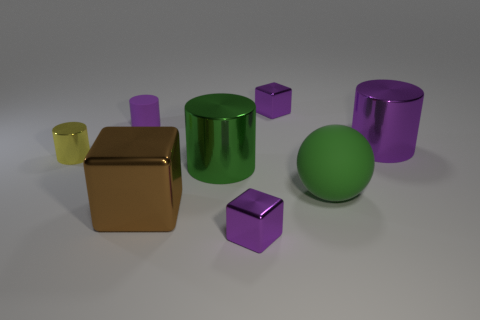Add 1 tiny cyan metal cylinders. How many objects exist? 9 Subtract 0 blue balls. How many objects are left? 8 Subtract all spheres. How many objects are left? 7 Subtract 2 cubes. How many cubes are left? 1 Subtract all yellow balls. Subtract all yellow cylinders. How many balls are left? 1 Subtract all brown cubes. How many red cylinders are left? 0 Subtract all big purple metallic cylinders. Subtract all tiny purple shiny objects. How many objects are left? 5 Add 5 large purple metallic cylinders. How many large purple metallic cylinders are left? 6 Add 1 tiny brown matte balls. How many tiny brown matte balls exist? 1 Subtract all brown blocks. How many blocks are left? 2 